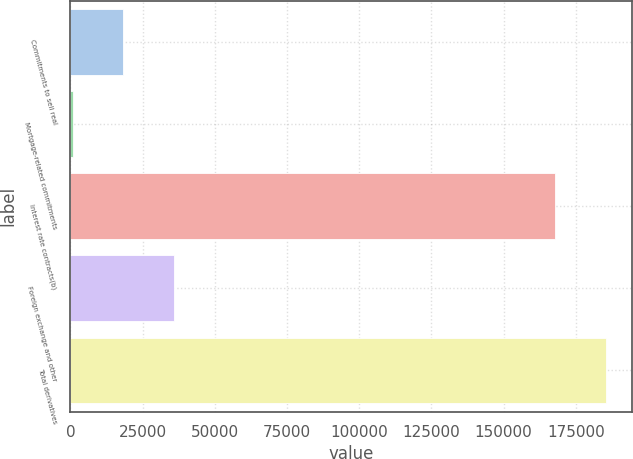Convert chart. <chart><loc_0><loc_0><loc_500><loc_500><bar_chart><fcel>Commitments to sell real<fcel>Mortgage-related commitments<fcel>Interest rate contracts(b)<fcel>Foreign exchange and other<fcel>Total derivatives<nl><fcel>18347.2<fcel>735<fcel>167737<fcel>35959.4<fcel>185349<nl></chart> 